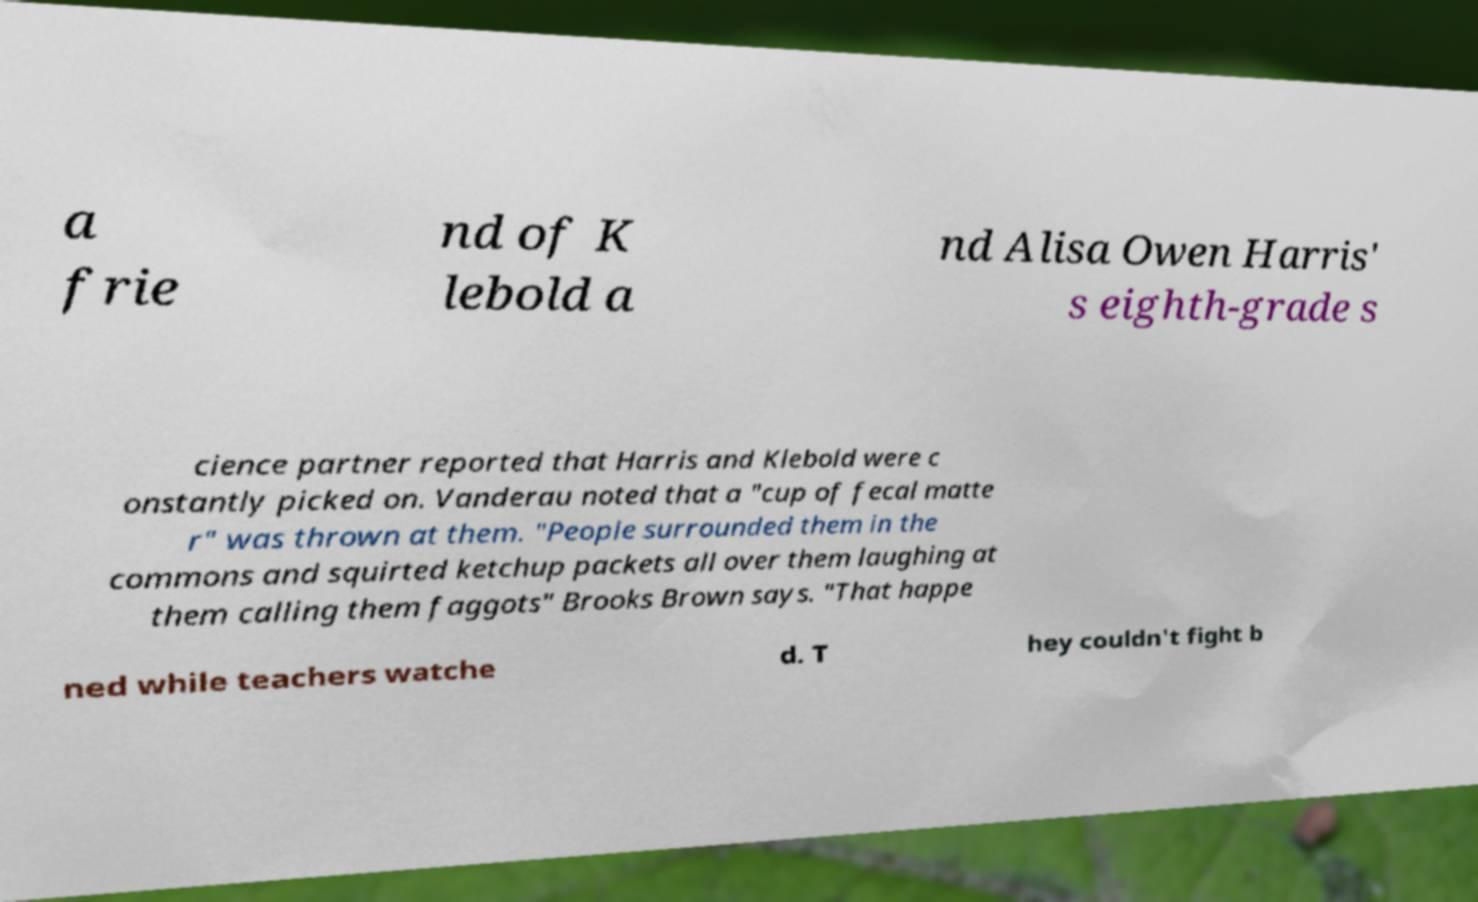I need the written content from this picture converted into text. Can you do that? a frie nd of K lebold a nd Alisa Owen Harris' s eighth-grade s cience partner reported that Harris and Klebold were c onstantly picked on. Vanderau noted that a "cup of fecal matte r" was thrown at them. "People surrounded them in the commons and squirted ketchup packets all over them laughing at them calling them faggots" Brooks Brown says. "That happe ned while teachers watche d. T hey couldn't fight b 